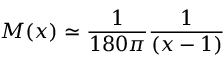Convert formula to latex. <formula><loc_0><loc_0><loc_500><loc_500>M ( x ) \simeq { \frac { 1 } { 1 8 0 \pi } } { \frac { 1 } { ( x - 1 ) } }</formula> 